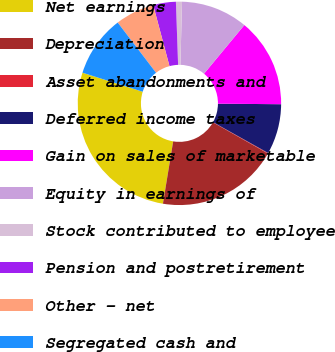<chart> <loc_0><loc_0><loc_500><loc_500><pie_chart><fcel>Net earnings<fcel>Depreciation<fcel>Asset abandonments and<fcel>Deferred income taxes<fcel>Gain on sales of marketable<fcel>Equity in earnings of<fcel>Stock contributed to employee<fcel>Pension and postretirement<fcel>Other - net<fcel>Segregated cash and<nl><fcel>27.28%<fcel>19.39%<fcel>0.09%<fcel>7.98%<fcel>14.12%<fcel>10.61%<fcel>0.96%<fcel>3.6%<fcel>6.23%<fcel>9.74%<nl></chart> 